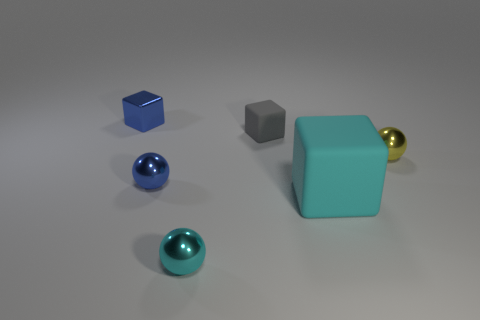Subtract all small cubes. How many cubes are left? 1 Subtract all cyan blocks. How many blocks are left? 2 Subtract 1 balls. How many balls are left? 2 Add 3 tiny gray blocks. How many objects exist? 9 Subtract all yellow blocks. Subtract all yellow cylinders. How many blocks are left? 3 Subtract all gray spheres. How many gray cubes are left? 1 Subtract all brown cylinders. Subtract all small yellow balls. How many objects are left? 5 Add 3 cyan matte blocks. How many cyan matte blocks are left? 4 Add 6 cyan spheres. How many cyan spheres exist? 7 Subtract 0 brown balls. How many objects are left? 6 